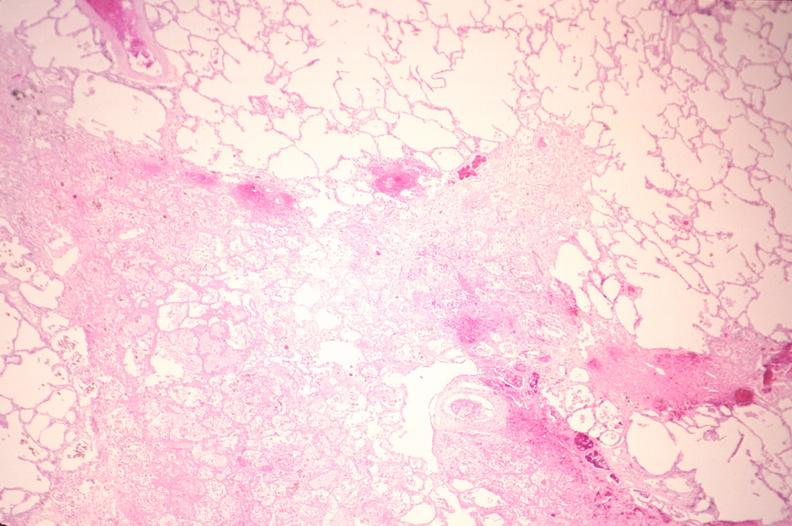does adrenal show lung, infarct, acute and organized?
Answer the question using a single word or phrase. No 